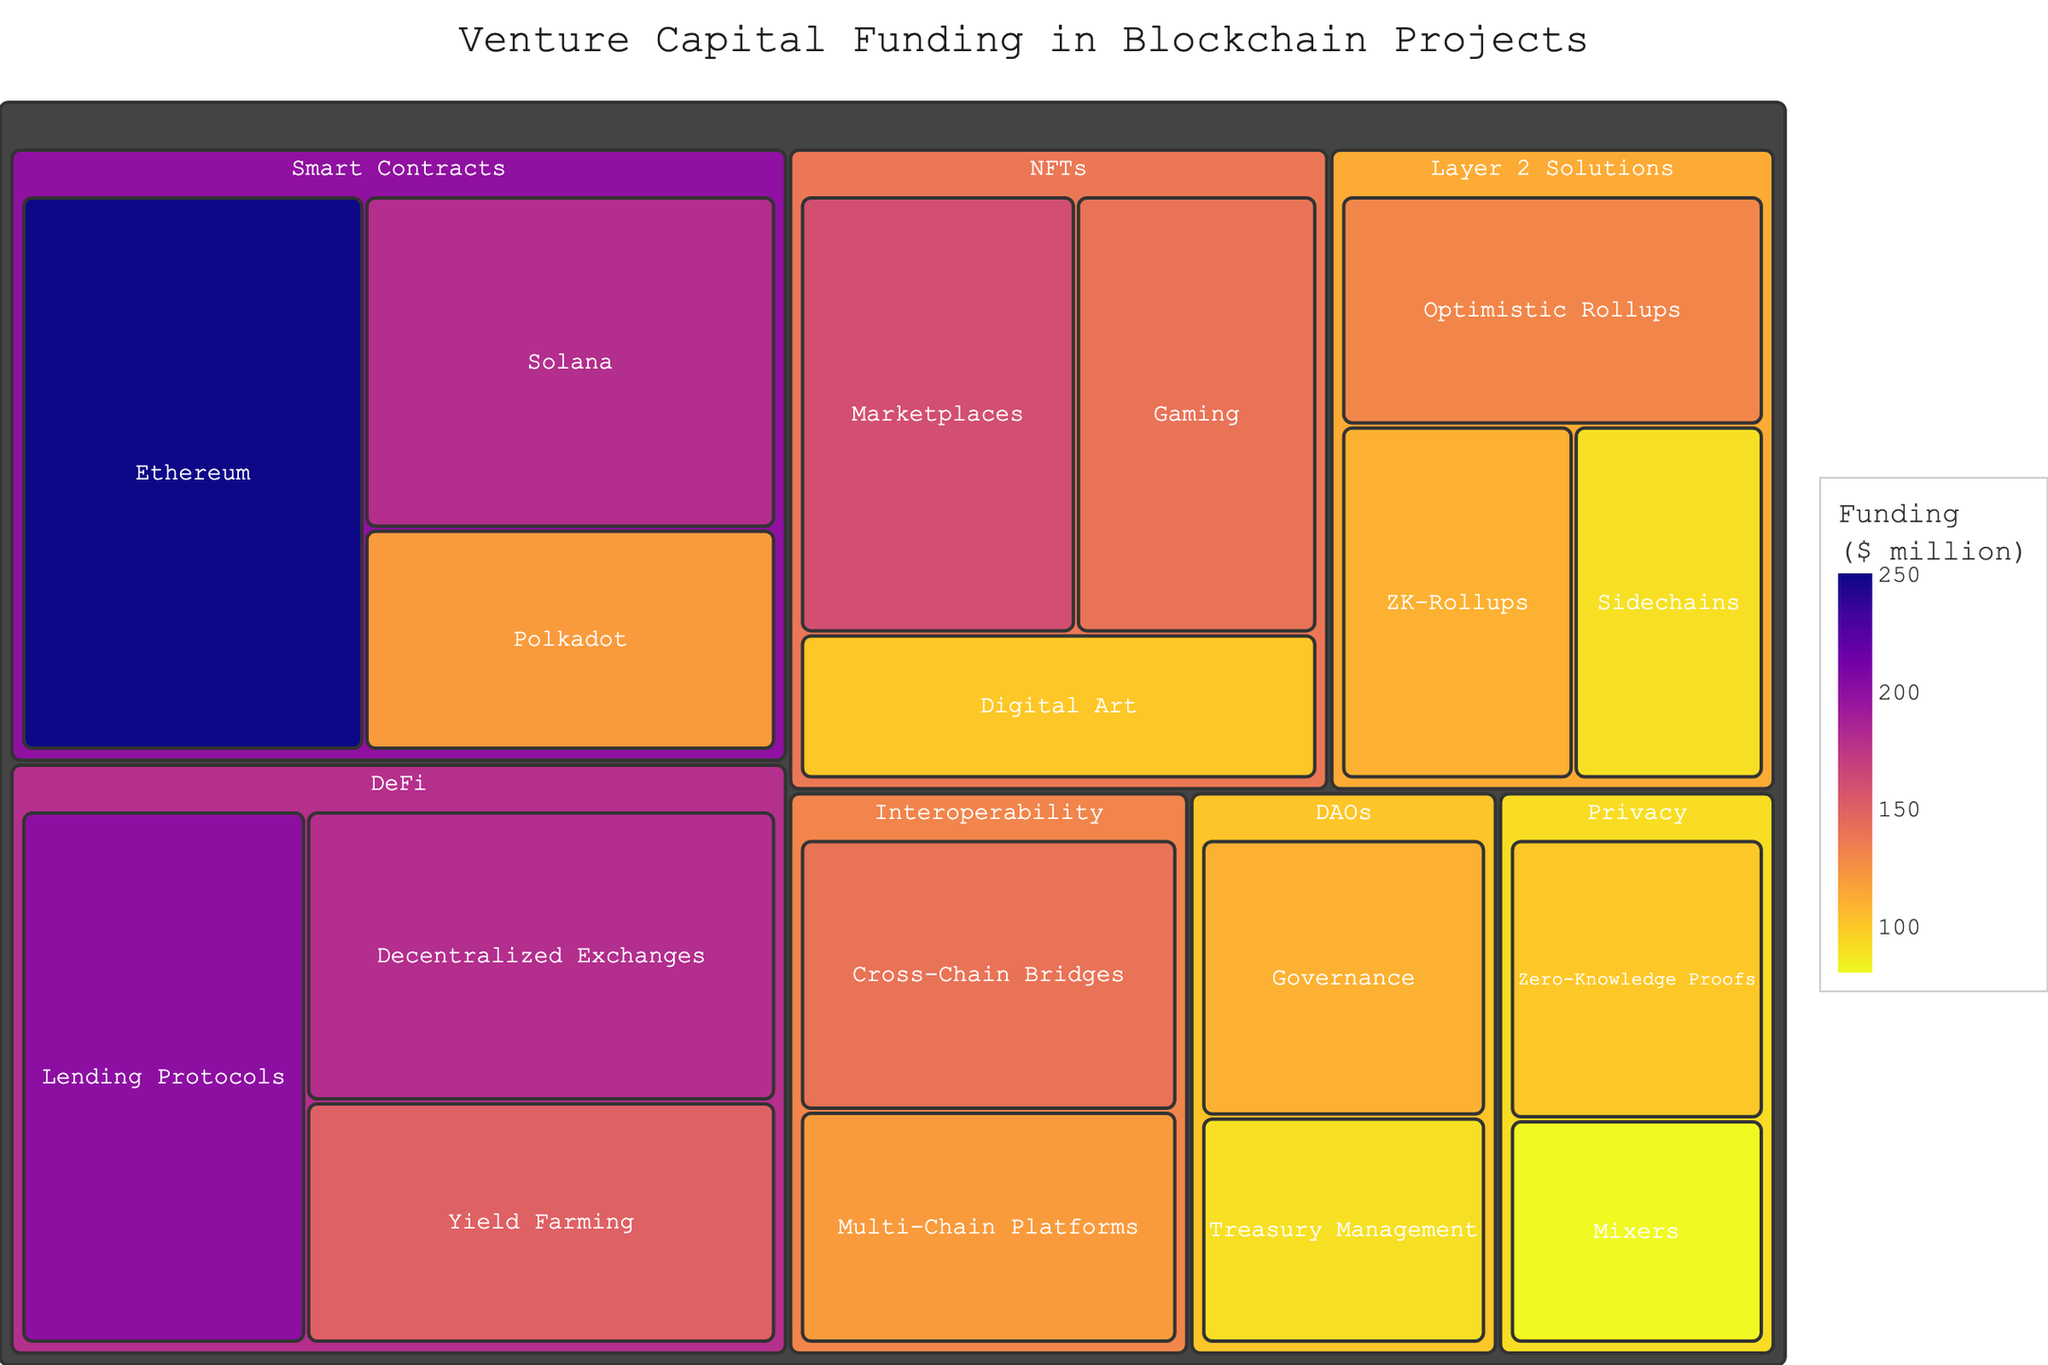Which category received the highest total funding? The category with the largest area in the treemap has the highest total funding, which is "Smart Contracts".
Answer: Smart Contracts How much venture capital funding was allocated to Privacy technologies in total? Sum the values for subcategories within the Privacy category: Zero-Knowledge Proofs (100) + Mixers (80) = 180 million dollars.
Answer: 180 million Which subcategory under DeFi received more funding, Lending Protocols or Yield Farming? Compare the funding values: Lending Protocols (200) vs Yield Farming (150). Lending Protocols has more.
Answer: Lending Protocols What's the difference in funding between Ethereum and Solana under Smart Contracts? Subtract the funding for Solana from Ethereum: 250 (Ethereum) - 180 (Solana) = 70 million dollars.
Answer: 70 million Which has more total funding: NFTs or DAOs? Sum the values for subcategories within both categories: NFTs (Marketplaces 160 + Gaming 140 + Digital Art 100 = 400) vs DAOs (Governance 110 + Treasury Management 90 = 200). NFTs have more.
Answer: NFTs Among the subcategories in Layer 2 Solutions, which has the least allocated funding? Compare the funding values for each subcategory within Layer 2 Solutions: Optimistic Rollups (130), ZK-Rollups (110), and Sidechains (90). Sidechains have the least.
Answer: Sidechains How does the funding for Decentralized Exchanges in DeFi compare to Cross-Chain Bridges in Interoperability? Compare the funding values: Decentralized Exchanges (180) vs Cross-Chain Bridges (140). Decentralized Exchanges received more.
Answer: Decentralized Exchanges Which category has a total funding closest to 400 million dollars? By comparing total funding values: NFTs (400 million, the sum of subcategories in NFTs).
Answer: NFTs What is the total funding for all technologies under Interoperability and Privacy combined? Sum the values for all subcategories under both categories: Interoperability (Cross-Chain Bridges 140 + Multi-Chain Platforms 120 = 260) + Privacy (Zero-Knowledge Proofs 100 + Mixers 80 = 180), total = 260 + 180 = 440 million dollars.
Answer: 440 million What is the average funding for subcategories within the Smart Contracts category? Sum the values of subcategories and divide by their count: (250 + 180 + 120) / 3 = 183.33 million dollars.
Answer: 183.33 million 